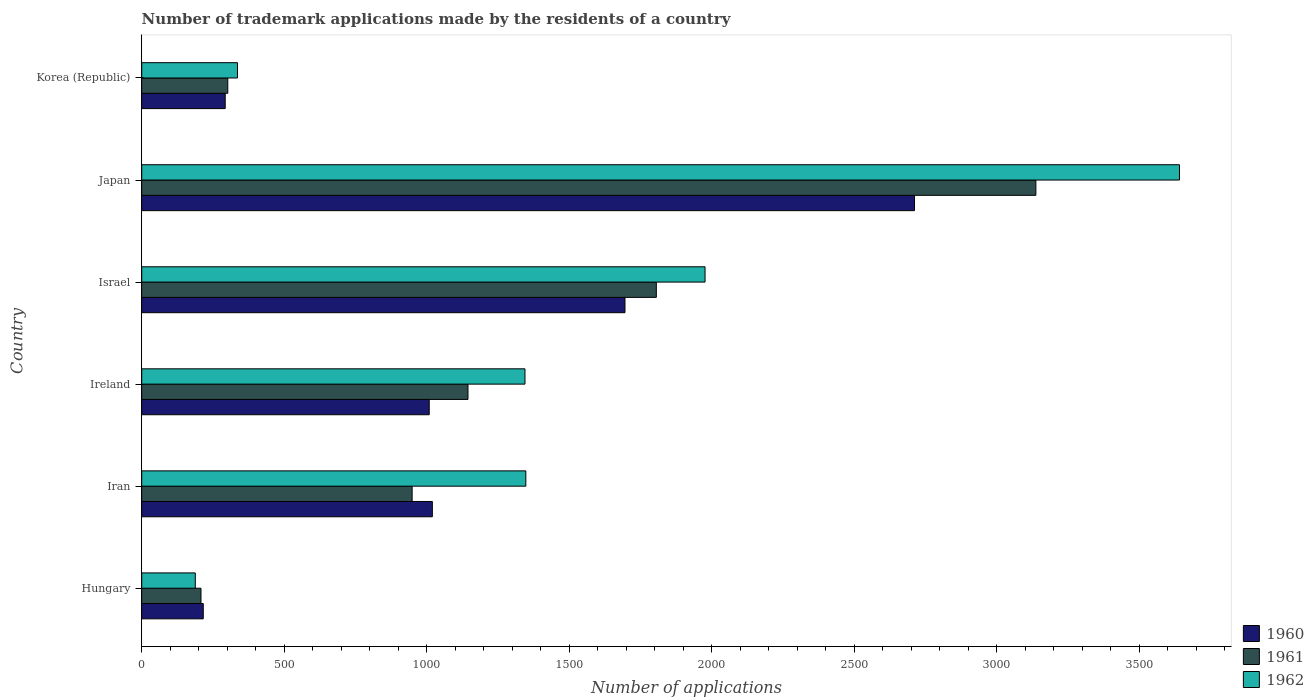Are the number of bars per tick equal to the number of legend labels?
Your answer should be very brief. Yes. How many bars are there on the 5th tick from the top?
Your answer should be very brief. 3. In how many cases, is the number of bars for a given country not equal to the number of legend labels?
Offer a terse response. 0. What is the number of trademark applications made by the residents in 1960 in Hungary?
Keep it short and to the point. 216. Across all countries, what is the maximum number of trademark applications made by the residents in 1960?
Provide a succinct answer. 2712. Across all countries, what is the minimum number of trademark applications made by the residents in 1961?
Offer a very short reply. 208. In which country was the number of trademark applications made by the residents in 1962 minimum?
Give a very brief answer. Hungary. What is the total number of trademark applications made by the residents in 1960 in the graph?
Provide a short and direct response. 6946. What is the difference between the number of trademark applications made by the residents in 1961 in Iran and that in Korea (Republic)?
Ensure brevity in your answer.  647. What is the difference between the number of trademark applications made by the residents in 1960 in Israel and the number of trademark applications made by the residents in 1961 in Hungary?
Give a very brief answer. 1488. What is the average number of trademark applications made by the residents in 1961 per country?
Make the answer very short. 1258. What is the difference between the number of trademark applications made by the residents in 1962 and number of trademark applications made by the residents in 1960 in Hungary?
Offer a terse response. -28. What is the ratio of the number of trademark applications made by the residents in 1962 in Hungary to that in Korea (Republic)?
Give a very brief answer. 0.56. Is the number of trademark applications made by the residents in 1961 in Japan less than that in Korea (Republic)?
Your answer should be compact. No. What is the difference between the highest and the second highest number of trademark applications made by the residents in 1962?
Offer a very short reply. 1665. What is the difference between the highest and the lowest number of trademark applications made by the residents in 1960?
Offer a very short reply. 2496. In how many countries, is the number of trademark applications made by the residents in 1962 greater than the average number of trademark applications made by the residents in 1962 taken over all countries?
Your response must be concise. 2. Is the sum of the number of trademark applications made by the residents in 1962 in Hungary and Iran greater than the maximum number of trademark applications made by the residents in 1961 across all countries?
Keep it short and to the point. No. What does the 2nd bar from the top in Iran represents?
Your answer should be compact. 1961. What does the 3rd bar from the bottom in Japan represents?
Ensure brevity in your answer.  1962. How many countries are there in the graph?
Make the answer very short. 6. What is the difference between two consecutive major ticks on the X-axis?
Your answer should be compact. 500. Does the graph contain grids?
Give a very brief answer. No. What is the title of the graph?
Provide a short and direct response. Number of trademark applications made by the residents of a country. Does "1987" appear as one of the legend labels in the graph?
Ensure brevity in your answer.  No. What is the label or title of the X-axis?
Make the answer very short. Number of applications. What is the label or title of the Y-axis?
Your answer should be compact. Country. What is the Number of applications in 1960 in Hungary?
Give a very brief answer. 216. What is the Number of applications of 1961 in Hungary?
Your answer should be very brief. 208. What is the Number of applications in 1962 in Hungary?
Your answer should be very brief. 188. What is the Number of applications of 1960 in Iran?
Provide a short and direct response. 1020. What is the Number of applications of 1961 in Iran?
Your answer should be compact. 949. What is the Number of applications of 1962 in Iran?
Provide a succinct answer. 1348. What is the Number of applications in 1960 in Ireland?
Keep it short and to the point. 1009. What is the Number of applications in 1961 in Ireland?
Offer a terse response. 1145. What is the Number of applications in 1962 in Ireland?
Your response must be concise. 1345. What is the Number of applications in 1960 in Israel?
Your response must be concise. 1696. What is the Number of applications of 1961 in Israel?
Give a very brief answer. 1806. What is the Number of applications of 1962 in Israel?
Offer a terse response. 1977. What is the Number of applications in 1960 in Japan?
Your answer should be very brief. 2712. What is the Number of applications of 1961 in Japan?
Give a very brief answer. 3138. What is the Number of applications of 1962 in Japan?
Your answer should be compact. 3642. What is the Number of applications of 1960 in Korea (Republic)?
Give a very brief answer. 293. What is the Number of applications of 1961 in Korea (Republic)?
Provide a short and direct response. 302. What is the Number of applications of 1962 in Korea (Republic)?
Provide a succinct answer. 336. Across all countries, what is the maximum Number of applications in 1960?
Provide a succinct answer. 2712. Across all countries, what is the maximum Number of applications in 1961?
Provide a succinct answer. 3138. Across all countries, what is the maximum Number of applications of 1962?
Ensure brevity in your answer.  3642. Across all countries, what is the minimum Number of applications of 1960?
Ensure brevity in your answer.  216. Across all countries, what is the minimum Number of applications of 1961?
Your answer should be very brief. 208. Across all countries, what is the minimum Number of applications of 1962?
Provide a succinct answer. 188. What is the total Number of applications of 1960 in the graph?
Your response must be concise. 6946. What is the total Number of applications in 1961 in the graph?
Your answer should be very brief. 7548. What is the total Number of applications of 1962 in the graph?
Ensure brevity in your answer.  8836. What is the difference between the Number of applications in 1960 in Hungary and that in Iran?
Offer a terse response. -804. What is the difference between the Number of applications in 1961 in Hungary and that in Iran?
Make the answer very short. -741. What is the difference between the Number of applications in 1962 in Hungary and that in Iran?
Your response must be concise. -1160. What is the difference between the Number of applications of 1960 in Hungary and that in Ireland?
Ensure brevity in your answer.  -793. What is the difference between the Number of applications of 1961 in Hungary and that in Ireland?
Offer a terse response. -937. What is the difference between the Number of applications of 1962 in Hungary and that in Ireland?
Offer a terse response. -1157. What is the difference between the Number of applications in 1960 in Hungary and that in Israel?
Provide a succinct answer. -1480. What is the difference between the Number of applications in 1961 in Hungary and that in Israel?
Your answer should be compact. -1598. What is the difference between the Number of applications of 1962 in Hungary and that in Israel?
Offer a very short reply. -1789. What is the difference between the Number of applications in 1960 in Hungary and that in Japan?
Keep it short and to the point. -2496. What is the difference between the Number of applications in 1961 in Hungary and that in Japan?
Your answer should be very brief. -2930. What is the difference between the Number of applications of 1962 in Hungary and that in Japan?
Your response must be concise. -3454. What is the difference between the Number of applications in 1960 in Hungary and that in Korea (Republic)?
Provide a succinct answer. -77. What is the difference between the Number of applications of 1961 in Hungary and that in Korea (Republic)?
Make the answer very short. -94. What is the difference between the Number of applications of 1962 in Hungary and that in Korea (Republic)?
Make the answer very short. -148. What is the difference between the Number of applications in 1961 in Iran and that in Ireland?
Provide a succinct answer. -196. What is the difference between the Number of applications in 1960 in Iran and that in Israel?
Offer a terse response. -676. What is the difference between the Number of applications in 1961 in Iran and that in Israel?
Provide a short and direct response. -857. What is the difference between the Number of applications of 1962 in Iran and that in Israel?
Offer a very short reply. -629. What is the difference between the Number of applications of 1960 in Iran and that in Japan?
Provide a short and direct response. -1692. What is the difference between the Number of applications of 1961 in Iran and that in Japan?
Ensure brevity in your answer.  -2189. What is the difference between the Number of applications of 1962 in Iran and that in Japan?
Make the answer very short. -2294. What is the difference between the Number of applications in 1960 in Iran and that in Korea (Republic)?
Your response must be concise. 727. What is the difference between the Number of applications of 1961 in Iran and that in Korea (Republic)?
Provide a succinct answer. 647. What is the difference between the Number of applications in 1962 in Iran and that in Korea (Republic)?
Offer a very short reply. 1012. What is the difference between the Number of applications of 1960 in Ireland and that in Israel?
Your answer should be compact. -687. What is the difference between the Number of applications of 1961 in Ireland and that in Israel?
Offer a very short reply. -661. What is the difference between the Number of applications in 1962 in Ireland and that in Israel?
Your answer should be very brief. -632. What is the difference between the Number of applications of 1960 in Ireland and that in Japan?
Keep it short and to the point. -1703. What is the difference between the Number of applications of 1961 in Ireland and that in Japan?
Give a very brief answer. -1993. What is the difference between the Number of applications in 1962 in Ireland and that in Japan?
Provide a short and direct response. -2297. What is the difference between the Number of applications in 1960 in Ireland and that in Korea (Republic)?
Keep it short and to the point. 716. What is the difference between the Number of applications of 1961 in Ireland and that in Korea (Republic)?
Give a very brief answer. 843. What is the difference between the Number of applications of 1962 in Ireland and that in Korea (Republic)?
Your answer should be compact. 1009. What is the difference between the Number of applications in 1960 in Israel and that in Japan?
Provide a short and direct response. -1016. What is the difference between the Number of applications in 1961 in Israel and that in Japan?
Provide a short and direct response. -1332. What is the difference between the Number of applications in 1962 in Israel and that in Japan?
Offer a terse response. -1665. What is the difference between the Number of applications of 1960 in Israel and that in Korea (Republic)?
Provide a short and direct response. 1403. What is the difference between the Number of applications of 1961 in Israel and that in Korea (Republic)?
Provide a succinct answer. 1504. What is the difference between the Number of applications of 1962 in Israel and that in Korea (Republic)?
Give a very brief answer. 1641. What is the difference between the Number of applications in 1960 in Japan and that in Korea (Republic)?
Your answer should be compact. 2419. What is the difference between the Number of applications in 1961 in Japan and that in Korea (Republic)?
Your response must be concise. 2836. What is the difference between the Number of applications of 1962 in Japan and that in Korea (Republic)?
Provide a short and direct response. 3306. What is the difference between the Number of applications in 1960 in Hungary and the Number of applications in 1961 in Iran?
Your response must be concise. -733. What is the difference between the Number of applications of 1960 in Hungary and the Number of applications of 1962 in Iran?
Your response must be concise. -1132. What is the difference between the Number of applications in 1961 in Hungary and the Number of applications in 1962 in Iran?
Provide a short and direct response. -1140. What is the difference between the Number of applications of 1960 in Hungary and the Number of applications of 1961 in Ireland?
Provide a succinct answer. -929. What is the difference between the Number of applications in 1960 in Hungary and the Number of applications in 1962 in Ireland?
Make the answer very short. -1129. What is the difference between the Number of applications of 1961 in Hungary and the Number of applications of 1962 in Ireland?
Make the answer very short. -1137. What is the difference between the Number of applications in 1960 in Hungary and the Number of applications in 1961 in Israel?
Offer a very short reply. -1590. What is the difference between the Number of applications of 1960 in Hungary and the Number of applications of 1962 in Israel?
Your answer should be very brief. -1761. What is the difference between the Number of applications of 1961 in Hungary and the Number of applications of 1962 in Israel?
Make the answer very short. -1769. What is the difference between the Number of applications of 1960 in Hungary and the Number of applications of 1961 in Japan?
Keep it short and to the point. -2922. What is the difference between the Number of applications of 1960 in Hungary and the Number of applications of 1962 in Japan?
Your response must be concise. -3426. What is the difference between the Number of applications of 1961 in Hungary and the Number of applications of 1962 in Japan?
Your answer should be very brief. -3434. What is the difference between the Number of applications in 1960 in Hungary and the Number of applications in 1961 in Korea (Republic)?
Provide a succinct answer. -86. What is the difference between the Number of applications in 1960 in Hungary and the Number of applications in 1962 in Korea (Republic)?
Provide a short and direct response. -120. What is the difference between the Number of applications of 1961 in Hungary and the Number of applications of 1962 in Korea (Republic)?
Your answer should be very brief. -128. What is the difference between the Number of applications of 1960 in Iran and the Number of applications of 1961 in Ireland?
Ensure brevity in your answer.  -125. What is the difference between the Number of applications of 1960 in Iran and the Number of applications of 1962 in Ireland?
Provide a short and direct response. -325. What is the difference between the Number of applications of 1961 in Iran and the Number of applications of 1962 in Ireland?
Make the answer very short. -396. What is the difference between the Number of applications of 1960 in Iran and the Number of applications of 1961 in Israel?
Keep it short and to the point. -786. What is the difference between the Number of applications of 1960 in Iran and the Number of applications of 1962 in Israel?
Your answer should be compact. -957. What is the difference between the Number of applications in 1961 in Iran and the Number of applications in 1962 in Israel?
Offer a terse response. -1028. What is the difference between the Number of applications of 1960 in Iran and the Number of applications of 1961 in Japan?
Your answer should be very brief. -2118. What is the difference between the Number of applications of 1960 in Iran and the Number of applications of 1962 in Japan?
Keep it short and to the point. -2622. What is the difference between the Number of applications in 1961 in Iran and the Number of applications in 1962 in Japan?
Offer a terse response. -2693. What is the difference between the Number of applications of 1960 in Iran and the Number of applications of 1961 in Korea (Republic)?
Make the answer very short. 718. What is the difference between the Number of applications in 1960 in Iran and the Number of applications in 1962 in Korea (Republic)?
Your response must be concise. 684. What is the difference between the Number of applications of 1961 in Iran and the Number of applications of 1962 in Korea (Republic)?
Your response must be concise. 613. What is the difference between the Number of applications of 1960 in Ireland and the Number of applications of 1961 in Israel?
Ensure brevity in your answer.  -797. What is the difference between the Number of applications in 1960 in Ireland and the Number of applications in 1962 in Israel?
Provide a short and direct response. -968. What is the difference between the Number of applications in 1961 in Ireland and the Number of applications in 1962 in Israel?
Give a very brief answer. -832. What is the difference between the Number of applications in 1960 in Ireland and the Number of applications in 1961 in Japan?
Provide a short and direct response. -2129. What is the difference between the Number of applications in 1960 in Ireland and the Number of applications in 1962 in Japan?
Make the answer very short. -2633. What is the difference between the Number of applications of 1961 in Ireland and the Number of applications of 1962 in Japan?
Your answer should be compact. -2497. What is the difference between the Number of applications in 1960 in Ireland and the Number of applications in 1961 in Korea (Republic)?
Your answer should be very brief. 707. What is the difference between the Number of applications of 1960 in Ireland and the Number of applications of 1962 in Korea (Republic)?
Give a very brief answer. 673. What is the difference between the Number of applications of 1961 in Ireland and the Number of applications of 1962 in Korea (Republic)?
Offer a very short reply. 809. What is the difference between the Number of applications of 1960 in Israel and the Number of applications of 1961 in Japan?
Ensure brevity in your answer.  -1442. What is the difference between the Number of applications of 1960 in Israel and the Number of applications of 1962 in Japan?
Offer a very short reply. -1946. What is the difference between the Number of applications in 1961 in Israel and the Number of applications in 1962 in Japan?
Your response must be concise. -1836. What is the difference between the Number of applications of 1960 in Israel and the Number of applications of 1961 in Korea (Republic)?
Provide a succinct answer. 1394. What is the difference between the Number of applications in 1960 in Israel and the Number of applications in 1962 in Korea (Republic)?
Ensure brevity in your answer.  1360. What is the difference between the Number of applications in 1961 in Israel and the Number of applications in 1962 in Korea (Republic)?
Ensure brevity in your answer.  1470. What is the difference between the Number of applications in 1960 in Japan and the Number of applications in 1961 in Korea (Republic)?
Offer a very short reply. 2410. What is the difference between the Number of applications of 1960 in Japan and the Number of applications of 1962 in Korea (Republic)?
Your answer should be compact. 2376. What is the difference between the Number of applications in 1961 in Japan and the Number of applications in 1962 in Korea (Republic)?
Ensure brevity in your answer.  2802. What is the average Number of applications of 1960 per country?
Make the answer very short. 1157.67. What is the average Number of applications in 1961 per country?
Keep it short and to the point. 1258. What is the average Number of applications in 1962 per country?
Your answer should be compact. 1472.67. What is the difference between the Number of applications in 1961 and Number of applications in 1962 in Hungary?
Your answer should be compact. 20. What is the difference between the Number of applications of 1960 and Number of applications of 1962 in Iran?
Your response must be concise. -328. What is the difference between the Number of applications in 1961 and Number of applications in 1962 in Iran?
Ensure brevity in your answer.  -399. What is the difference between the Number of applications in 1960 and Number of applications in 1961 in Ireland?
Provide a succinct answer. -136. What is the difference between the Number of applications of 1960 and Number of applications of 1962 in Ireland?
Give a very brief answer. -336. What is the difference between the Number of applications of 1961 and Number of applications of 1962 in Ireland?
Offer a very short reply. -200. What is the difference between the Number of applications of 1960 and Number of applications of 1961 in Israel?
Make the answer very short. -110. What is the difference between the Number of applications of 1960 and Number of applications of 1962 in Israel?
Offer a very short reply. -281. What is the difference between the Number of applications in 1961 and Number of applications in 1962 in Israel?
Keep it short and to the point. -171. What is the difference between the Number of applications of 1960 and Number of applications of 1961 in Japan?
Provide a succinct answer. -426. What is the difference between the Number of applications in 1960 and Number of applications in 1962 in Japan?
Keep it short and to the point. -930. What is the difference between the Number of applications in 1961 and Number of applications in 1962 in Japan?
Your answer should be compact. -504. What is the difference between the Number of applications in 1960 and Number of applications in 1962 in Korea (Republic)?
Provide a succinct answer. -43. What is the difference between the Number of applications of 1961 and Number of applications of 1962 in Korea (Republic)?
Your response must be concise. -34. What is the ratio of the Number of applications in 1960 in Hungary to that in Iran?
Your answer should be very brief. 0.21. What is the ratio of the Number of applications in 1961 in Hungary to that in Iran?
Provide a succinct answer. 0.22. What is the ratio of the Number of applications of 1962 in Hungary to that in Iran?
Offer a terse response. 0.14. What is the ratio of the Number of applications of 1960 in Hungary to that in Ireland?
Give a very brief answer. 0.21. What is the ratio of the Number of applications of 1961 in Hungary to that in Ireland?
Provide a short and direct response. 0.18. What is the ratio of the Number of applications of 1962 in Hungary to that in Ireland?
Offer a terse response. 0.14. What is the ratio of the Number of applications of 1960 in Hungary to that in Israel?
Keep it short and to the point. 0.13. What is the ratio of the Number of applications in 1961 in Hungary to that in Israel?
Offer a very short reply. 0.12. What is the ratio of the Number of applications in 1962 in Hungary to that in Israel?
Offer a very short reply. 0.1. What is the ratio of the Number of applications in 1960 in Hungary to that in Japan?
Your response must be concise. 0.08. What is the ratio of the Number of applications in 1961 in Hungary to that in Japan?
Keep it short and to the point. 0.07. What is the ratio of the Number of applications in 1962 in Hungary to that in Japan?
Your answer should be very brief. 0.05. What is the ratio of the Number of applications of 1960 in Hungary to that in Korea (Republic)?
Keep it short and to the point. 0.74. What is the ratio of the Number of applications in 1961 in Hungary to that in Korea (Republic)?
Keep it short and to the point. 0.69. What is the ratio of the Number of applications in 1962 in Hungary to that in Korea (Republic)?
Your answer should be very brief. 0.56. What is the ratio of the Number of applications in 1960 in Iran to that in Ireland?
Your answer should be compact. 1.01. What is the ratio of the Number of applications in 1961 in Iran to that in Ireland?
Your response must be concise. 0.83. What is the ratio of the Number of applications in 1962 in Iran to that in Ireland?
Give a very brief answer. 1. What is the ratio of the Number of applications of 1960 in Iran to that in Israel?
Offer a very short reply. 0.6. What is the ratio of the Number of applications of 1961 in Iran to that in Israel?
Make the answer very short. 0.53. What is the ratio of the Number of applications in 1962 in Iran to that in Israel?
Offer a very short reply. 0.68. What is the ratio of the Number of applications of 1960 in Iran to that in Japan?
Give a very brief answer. 0.38. What is the ratio of the Number of applications in 1961 in Iran to that in Japan?
Provide a short and direct response. 0.3. What is the ratio of the Number of applications of 1962 in Iran to that in Japan?
Provide a succinct answer. 0.37. What is the ratio of the Number of applications in 1960 in Iran to that in Korea (Republic)?
Ensure brevity in your answer.  3.48. What is the ratio of the Number of applications in 1961 in Iran to that in Korea (Republic)?
Provide a succinct answer. 3.14. What is the ratio of the Number of applications of 1962 in Iran to that in Korea (Republic)?
Ensure brevity in your answer.  4.01. What is the ratio of the Number of applications in 1960 in Ireland to that in Israel?
Offer a terse response. 0.59. What is the ratio of the Number of applications of 1961 in Ireland to that in Israel?
Keep it short and to the point. 0.63. What is the ratio of the Number of applications of 1962 in Ireland to that in Israel?
Keep it short and to the point. 0.68. What is the ratio of the Number of applications of 1960 in Ireland to that in Japan?
Give a very brief answer. 0.37. What is the ratio of the Number of applications of 1961 in Ireland to that in Japan?
Provide a short and direct response. 0.36. What is the ratio of the Number of applications of 1962 in Ireland to that in Japan?
Provide a succinct answer. 0.37. What is the ratio of the Number of applications of 1960 in Ireland to that in Korea (Republic)?
Keep it short and to the point. 3.44. What is the ratio of the Number of applications in 1961 in Ireland to that in Korea (Republic)?
Make the answer very short. 3.79. What is the ratio of the Number of applications of 1962 in Ireland to that in Korea (Republic)?
Offer a terse response. 4. What is the ratio of the Number of applications in 1960 in Israel to that in Japan?
Ensure brevity in your answer.  0.63. What is the ratio of the Number of applications of 1961 in Israel to that in Japan?
Provide a succinct answer. 0.58. What is the ratio of the Number of applications in 1962 in Israel to that in Japan?
Give a very brief answer. 0.54. What is the ratio of the Number of applications of 1960 in Israel to that in Korea (Republic)?
Offer a very short reply. 5.79. What is the ratio of the Number of applications in 1961 in Israel to that in Korea (Republic)?
Your answer should be compact. 5.98. What is the ratio of the Number of applications of 1962 in Israel to that in Korea (Republic)?
Keep it short and to the point. 5.88. What is the ratio of the Number of applications in 1960 in Japan to that in Korea (Republic)?
Keep it short and to the point. 9.26. What is the ratio of the Number of applications of 1961 in Japan to that in Korea (Republic)?
Provide a succinct answer. 10.39. What is the ratio of the Number of applications of 1962 in Japan to that in Korea (Republic)?
Ensure brevity in your answer.  10.84. What is the difference between the highest and the second highest Number of applications of 1960?
Your answer should be very brief. 1016. What is the difference between the highest and the second highest Number of applications in 1961?
Offer a very short reply. 1332. What is the difference between the highest and the second highest Number of applications of 1962?
Keep it short and to the point. 1665. What is the difference between the highest and the lowest Number of applications in 1960?
Provide a short and direct response. 2496. What is the difference between the highest and the lowest Number of applications in 1961?
Your answer should be very brief. 2930. What is the difference between the highest and the lowest Number of applications in 1962?
Make the answer very short. 3454. 